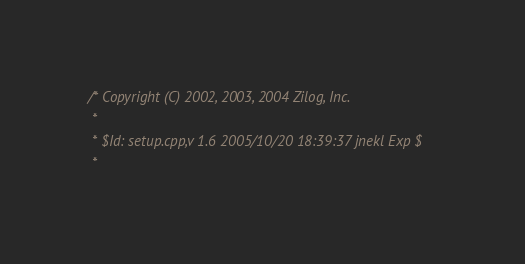<code> <loc_0><loc_0><loc_500><loc_500><_C++_>/* Copyright (C) 2002, 2003, 2004 Zilog, Inc.
 *
 * $Id: setup.cpp,v 1.6 2005/10/20 18:39:37 jnekl Exp $
 *</code> 